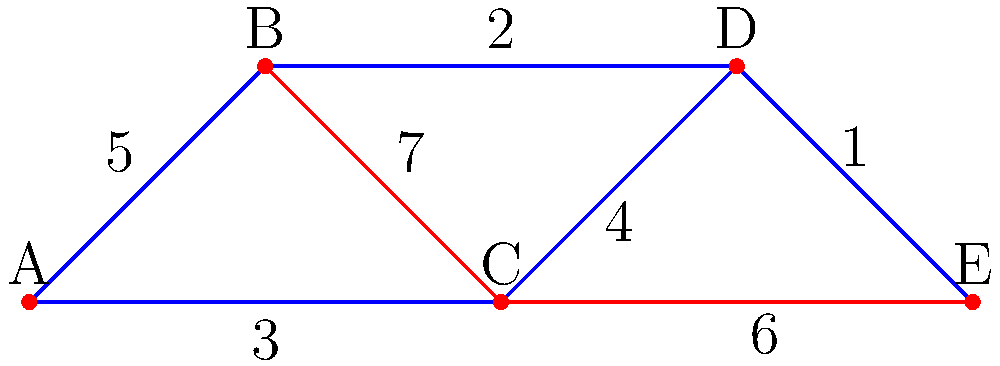In a public policy implementation project, five districts (A, B, C, D, E) need to be connected with infrastructure. The graph represents the possible connections between districts, with edge weights indicating the cost (in millions of dollars) to establish each connection. Using Kruskal's algorithm for finding the minimum spanning tree, determine the total cost of optimally connecting all districts. Which connection should be established last? To solve this problem using Kruskal's algorithm for finding the minimum spanning tree, we'll follow these steps:

1. Sort all edges by weight in ascending order:
   (D,E): 1
   (B,D): 2
   (A,C): 3
   (C,D): 4
   (A,B): 5
   (C,E): 6
   (B,C): 7

2. Start with an empty set of edges and add edges in order, skipping those that would create a cycle:

   a. Add (D,E): 1 (Total cost: 1)
   b. Add (B,D): 2 (Total cost: 3)
   c. Add (A,C): 3 (Total cost: 6)
   d. Add (C,D): 4 (Total cost: 10)
   e. Skip (A,B): 5 (would create a cycle)
   f. Skip (C,E): 6 (would create a cycle)
   g. Skip (B,C): 7 (would create a cycle)

3. The minimum spanning tree is complete with 4 edges (n-1, where n is the number of vertices).

4. The total cost is the sum of the weights of the selected edges: 1 + 2 + 3 + 4 = 10 million dollars.

5. The last connection to be established is (C,D) with a cost of 4 million dollars.
Answer: $10 million; (C,D) 